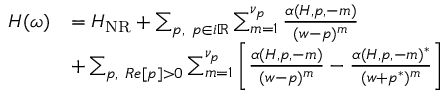<formula> <loc_0><loc_0><loc_500><loc_500>\begin{array} { r } { \begin{array} { r l } { H ( \omega ) } & { = H _ { N R } + \sum _ { p , p \in i \mathbb { R } } \sum _ { m = 1 } ^ { \nu _ { p } } \frac { \alpha ( H , p , - m ) } { ( w - p ) ^ { m } } } \\ & { + \sum _ { p , R e [ p ] > 0 } \sum _ { m = 1 } ^ { \nu _ { p } } \left [ \frac { \alpha ( H , p , - m ) } { ( w - p ) ^ { m } } - \frac { \alpha ( H , p , - m ) ^ { * } } { ( w + p ^ { * } ) ^ { m } } \right ] } \end{array} } \end{array}</formula> 